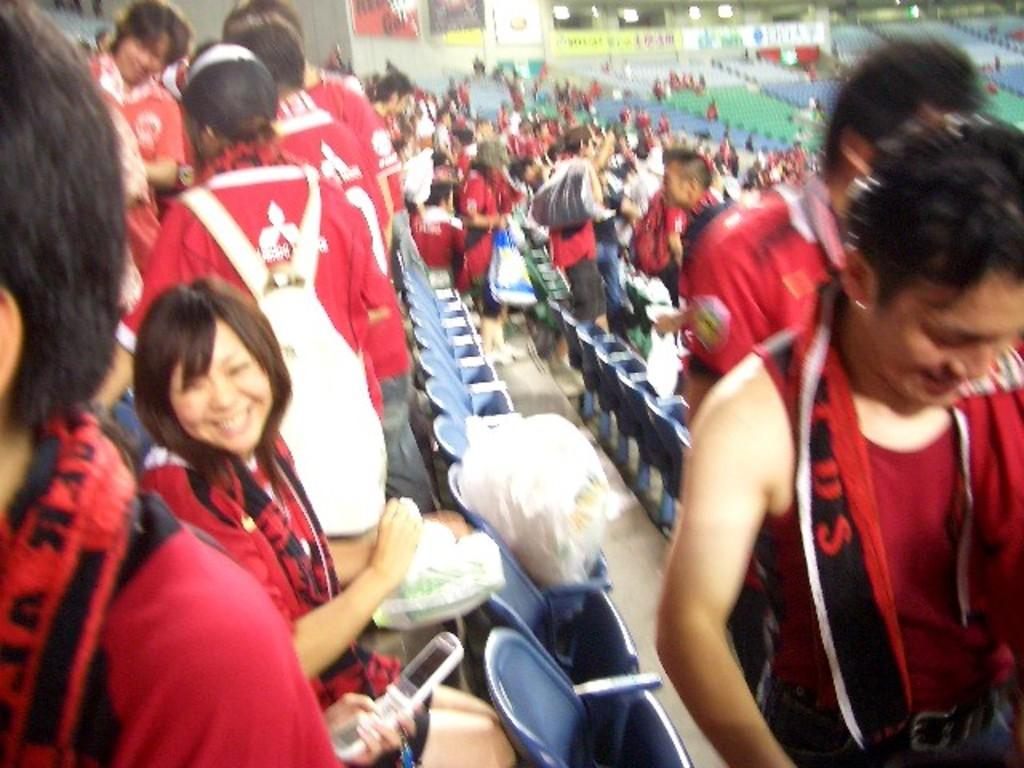What is the main subject of the image? The main subject of the image is a group of people. What are the people in the image doing? Some people are sitting, while others are walking. How can you identify the people who are walking? The people holding bags are walking. What color are the dresses worn by the people in the image? The people are wearing red-colored dresses. What type of furniture is visible in the image? There are chairs visible in the image. What type of road can be seen in the image? There is no road visible in the image; it features a group of people wearing red-colored dresses. What is the zinc content of the chairs in the image? There is no information about the zinc content of the chairs in the image, as the focus is on the people and their actions. 